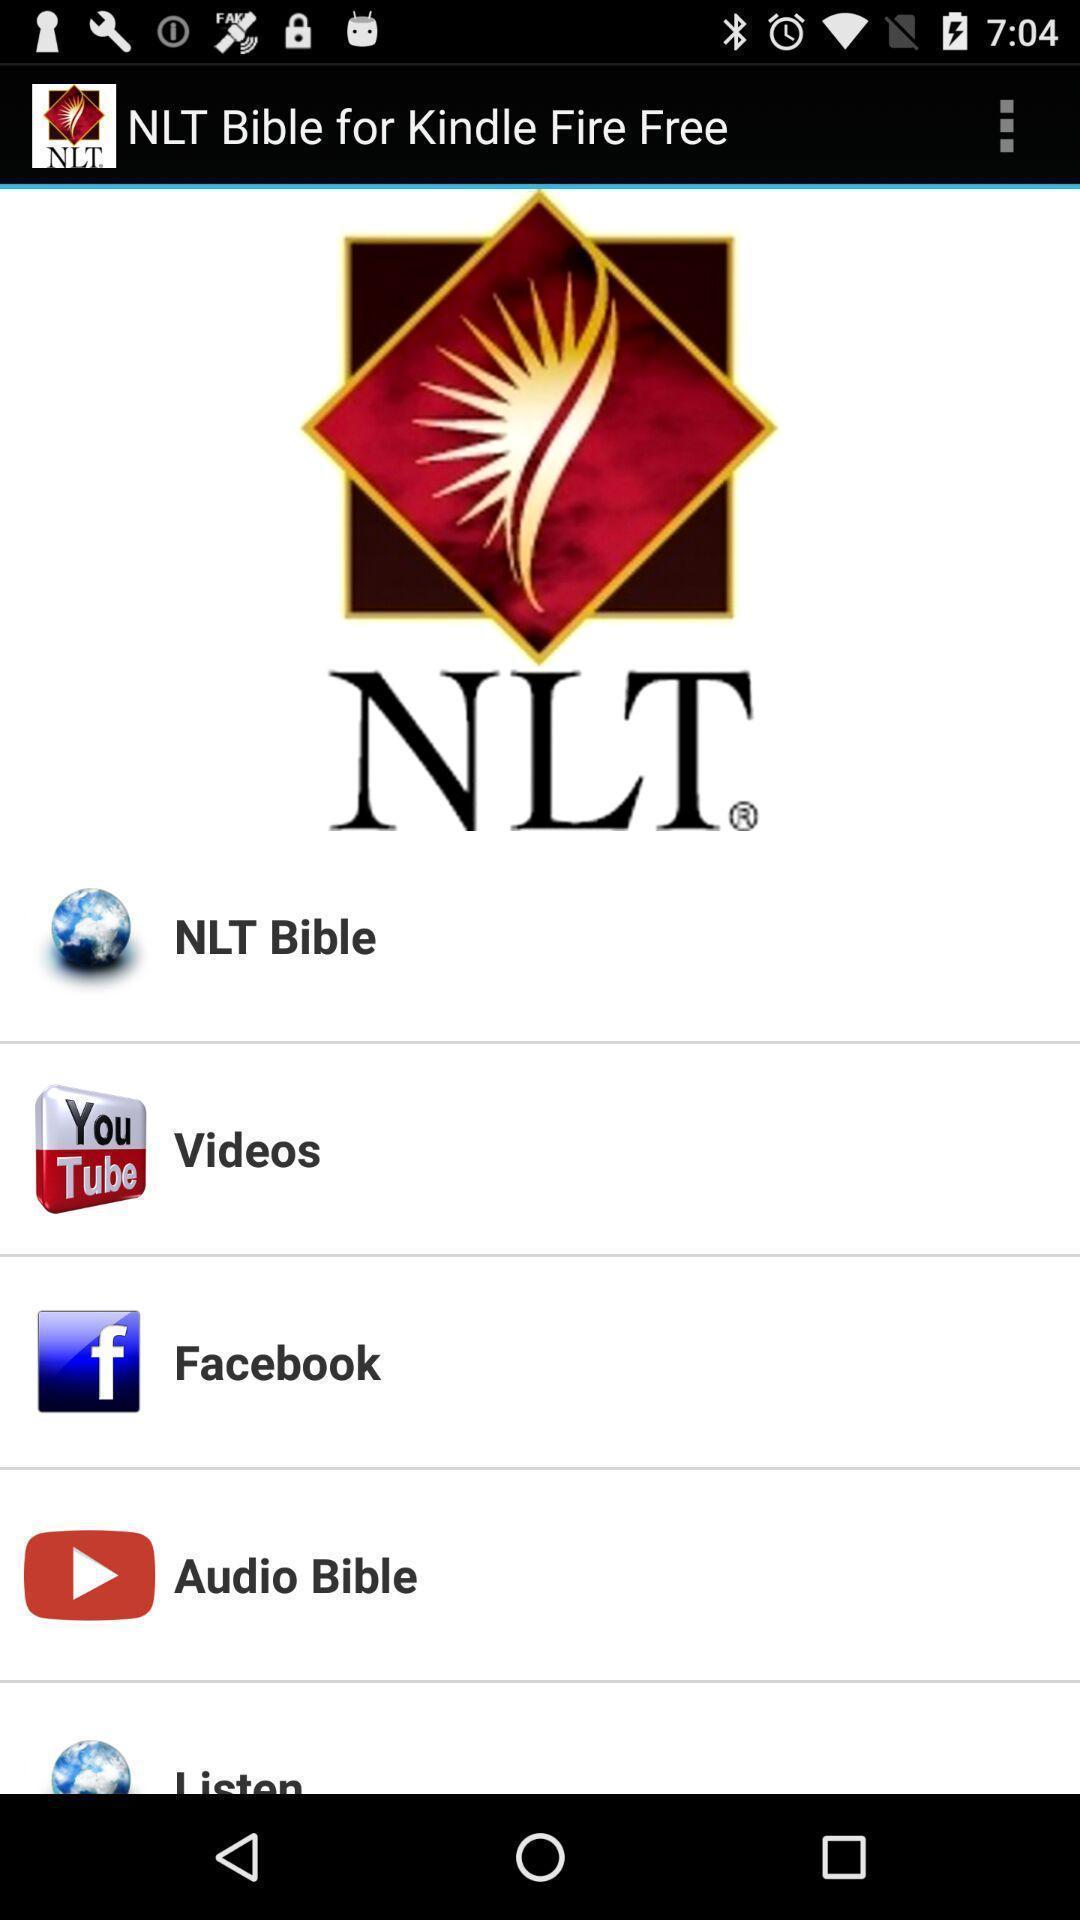What details can you identify in this image? Screen shows multiple options. 